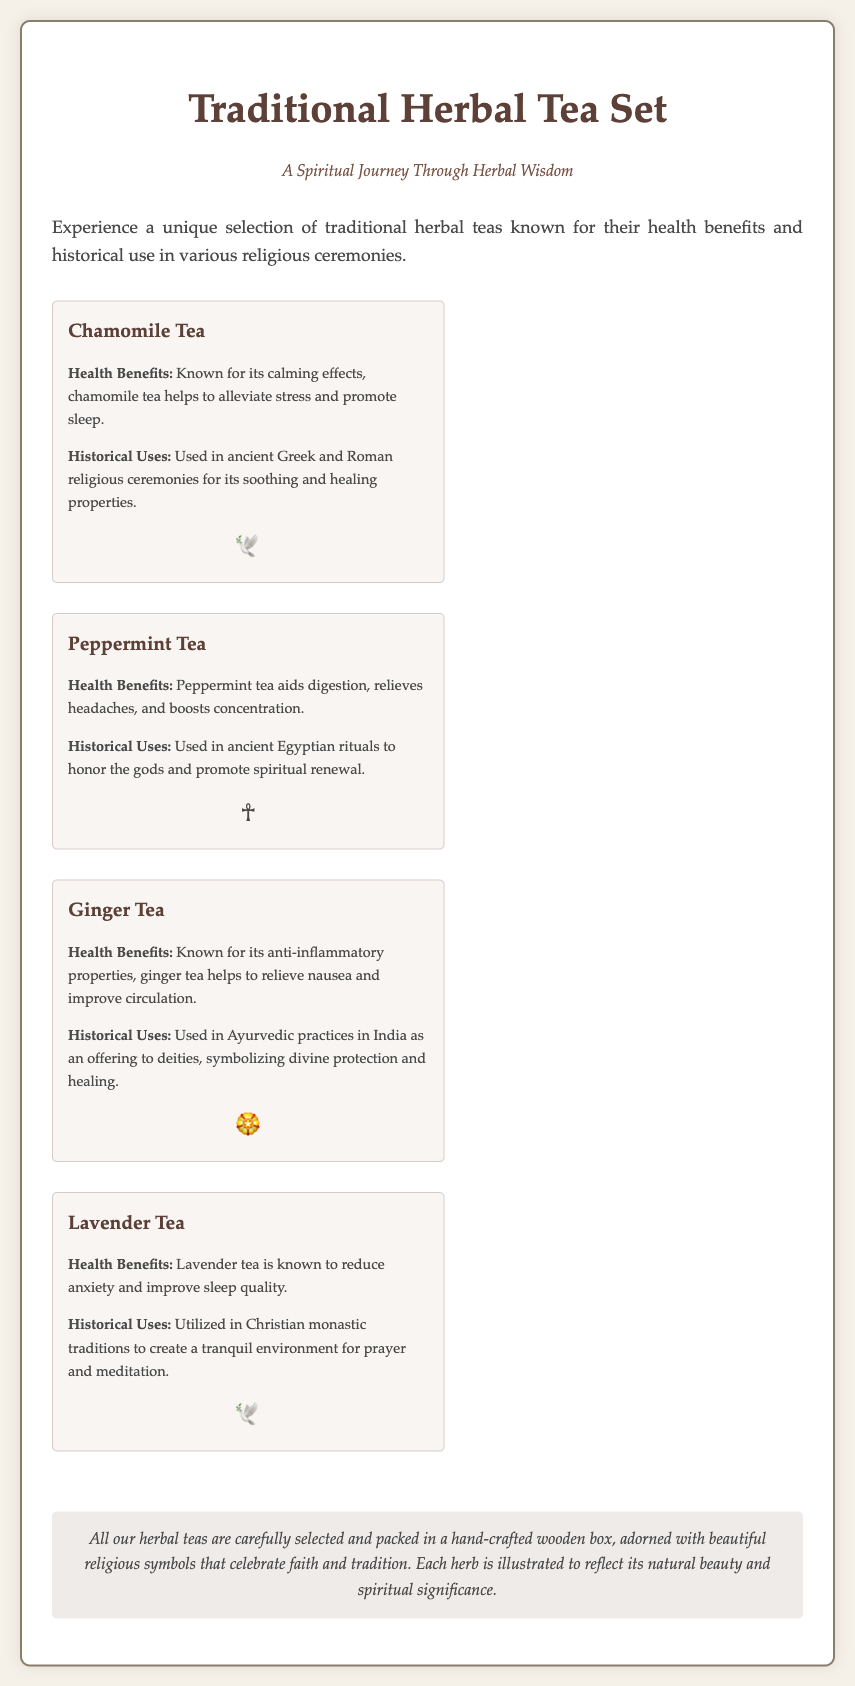What are the health benefits of Chamomile Tea? Chamomile tea helps to alleviate stress and promote sleep.
Answer: Alleviate stress and promote sleep What religious symbol is associated with Ginger Tea? The document lists a religious symbol alongside the information for each tea; Ginger Tea is associated with the symbol of a rose.
Answer: 🏵️ How is Lavender Tea historically used? Lavender tea is utilized in Christian monastic traditions to create a tranquil environment for prayer and meditation.
Answer: For prayer and meditation What is the tagline of the Traditional Herbal Tea Set? The tagline is presented prominently underneath the title of the document, emphasizing the thematic focus of the product.
Answer: A Spiritual Journey Through Herbal Wisdom How many tea selections are included in the packaging? The packaging details four different herbal tea selections, each described with its benefits and historical uses.
Answer: Four Which tea aids digestion? The description for Peppermint Tea specifically mentions aiding digestion as one of its health benefits.
Answer: Peppermint Tea What type of box is the tea set packaged in? The tea set is packaged in a hand-crafted wooden box, which is mentioned in the packaging description.
Answer: Wooden box What herb is known for reducing anxiety? Lavender Tea is explicitly mentioned as being known to reduce anxiety.
Answer: Lavender Tea What is the main theme celebrated in the design of the packaging? The packaging is adorned with beautiful religious symbols that celebrate faith and tradition.
Answer: Faith and tradition 